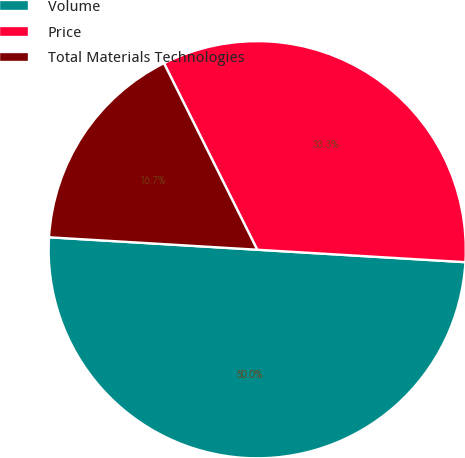Convert chart. <chart><loc_0><loc_0><loc_500><loc_500><pie_chart><fcel>Volume<fcel>Price<fcel>Total Materials Technologies<nl><fcel>50.0%<fcel>33.33%<fcel>16.67%<nl></chart> 